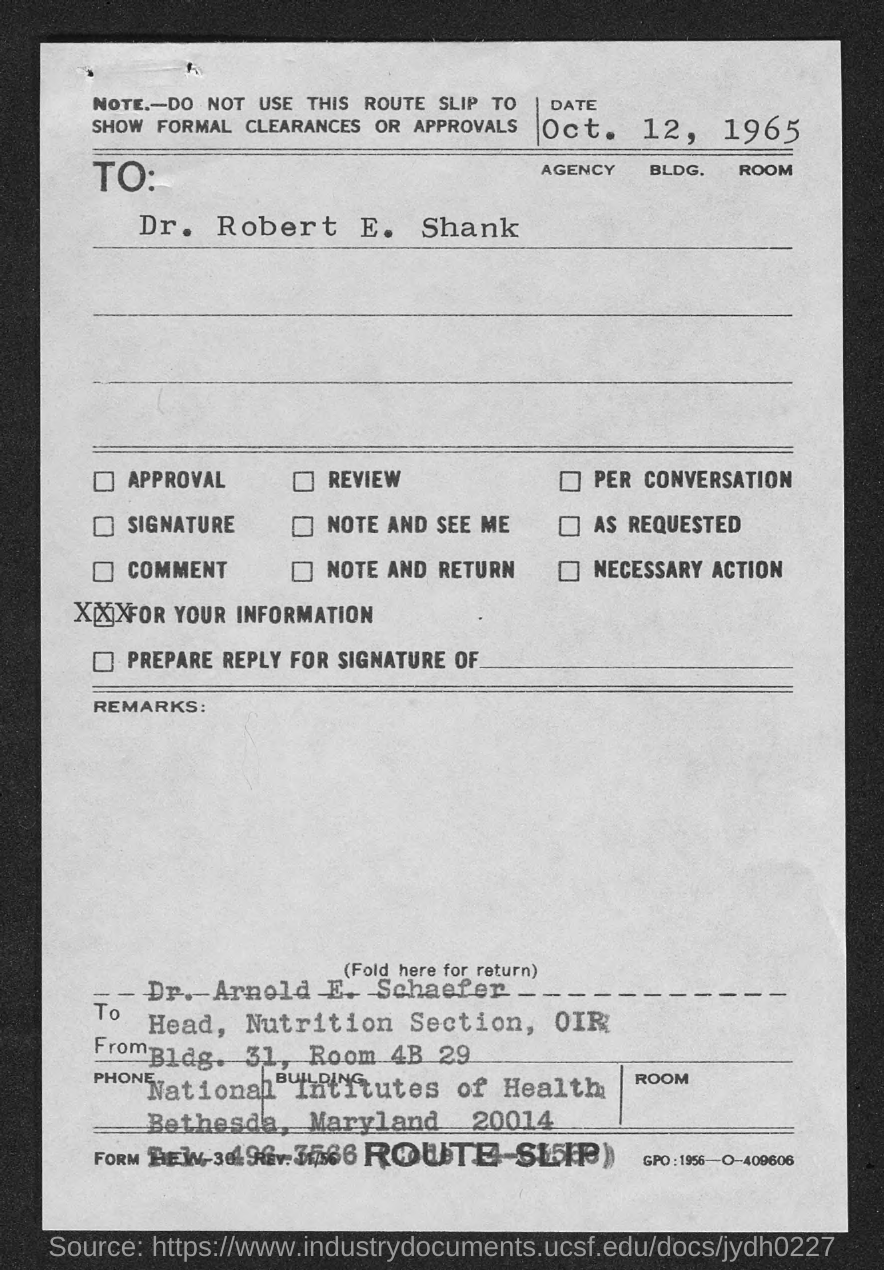Specify some key components in this picture. I have a question regarding a document called 'What is the slip? ROUTE SLIP..'. Can you please provide more information about it? The slip is addressed to Dr. Robert E. Shank. The slip is dated October 12, 1965. What is the text located at the bottom right corner of the page, specifically the GPO number? 